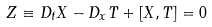<formula> <loc_0><loc_0><loc_500><loc_500>Z \equiv D _ { t } X - D _ { x } T + [ X , T ] = 0</formula> 